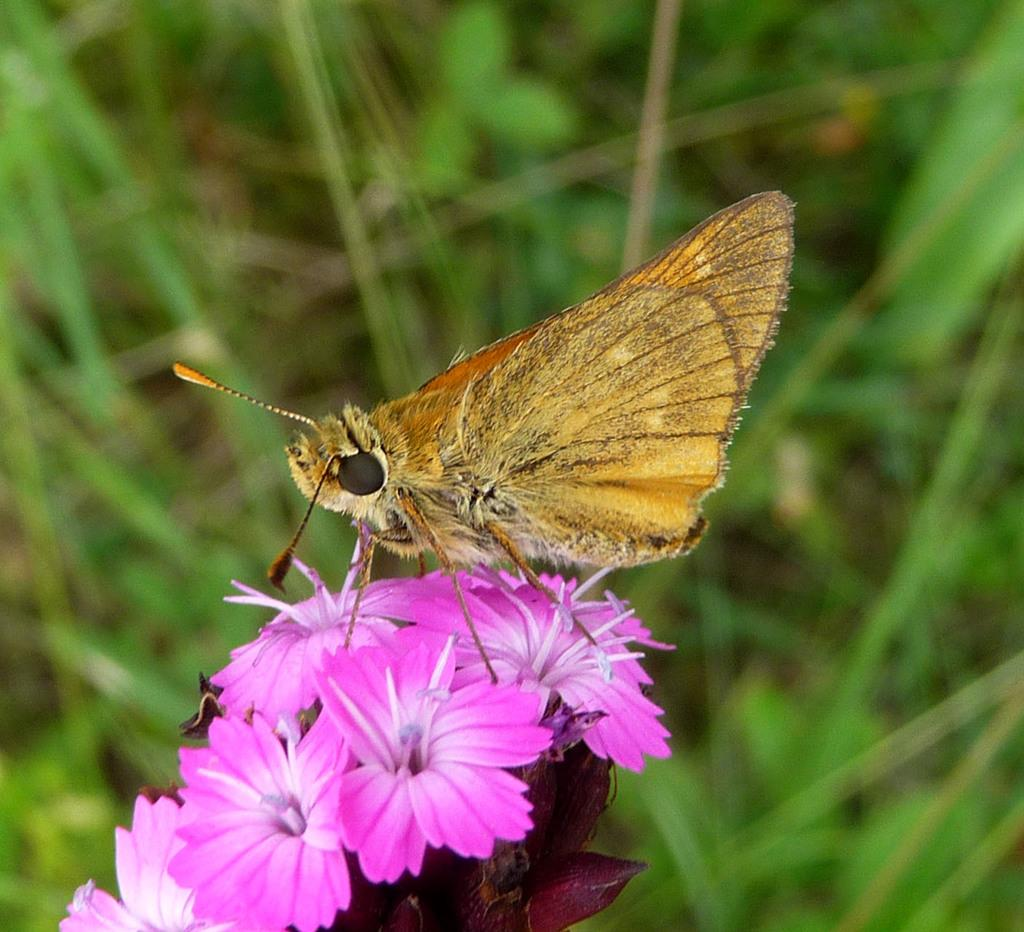What is the main subject of the image? There is a butterfly in the image. Where is the butterfly located? The butterfly is on flowers. What can be seen in the background of the image? There are plants in the background of the image. How many stars can be seen in the image? There are no stars visible in the image; it features a butterfly on flowers with plants in the background. Are there any dogs present in the image? There are no dogs present in the image; it features a butterfly on flowers with plants in the background. 